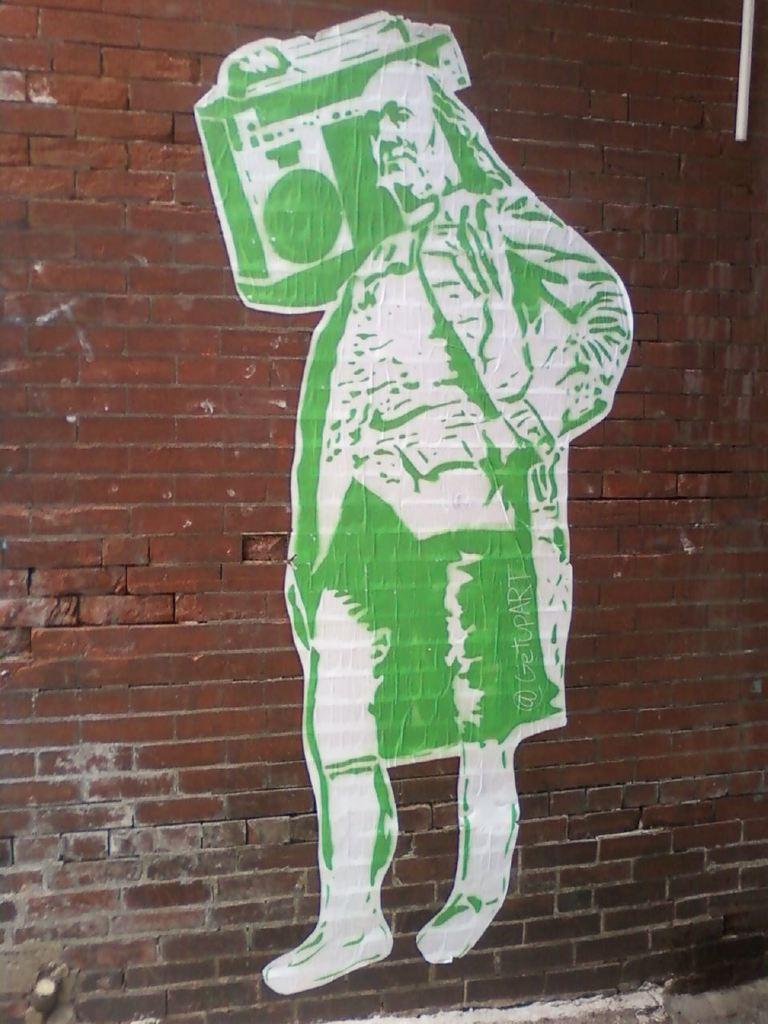What is the main subject of the painting in the image? There is a painting of a person in the image. What is the person in the painting holding? The person in the painting is holding an object. What can be seen on the wall in the image? There is text on the wall in the image. What architectural feature is visible at the top of the image? There is a pipe visible at the top of the image. What type of rock is the person in the painting standing on? There is no rock visible in the image; the person is in a painting, not standing on a rock. 